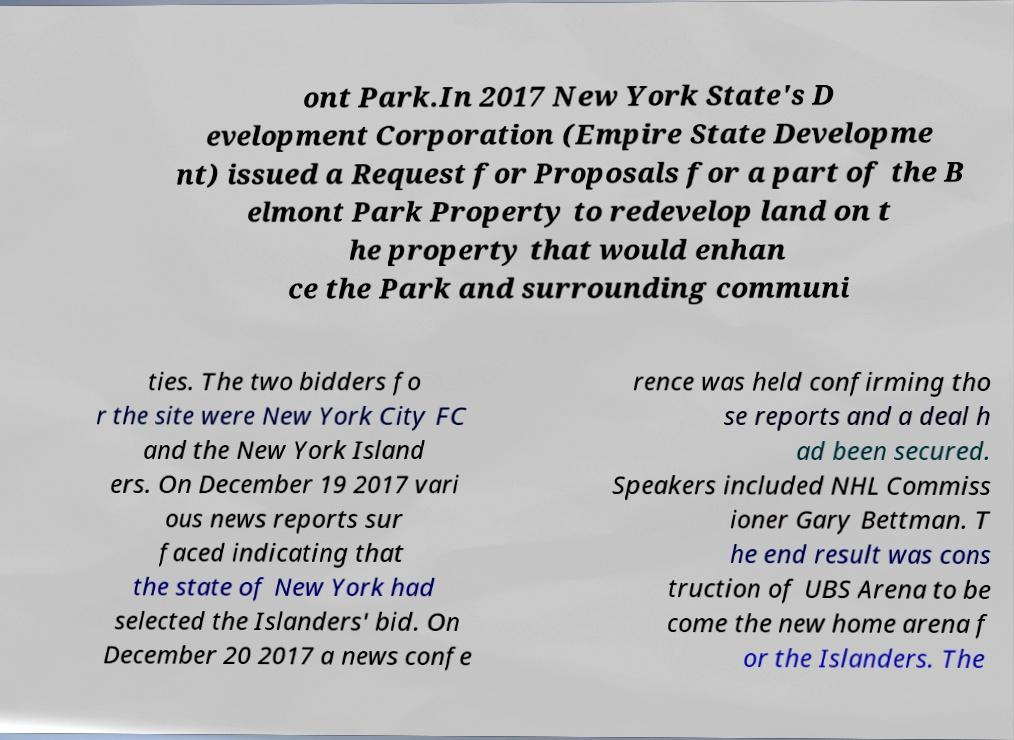For documentation purposes, I need the text within this image transcribed. Could you provide that? ont Park.In 2017 New York State's D evelopment Corporation (Empire State Developme nt) issued a Request for Proposals for a part of the B elmont Park Property to redevelop land on t he property that would enhan ce the Park and surrounding communi ties. The two bidders fo r the site were New York City FC and the New York Island ers. On December 19 2017 vari ous news reports sur faced indicating that the state of New York had selected the Islanders' bid. On December 20 2017 a news confe rence was held confirming tho se reports and a deal h ad been secured. Speakers included NHL Commiss ioner Gary Bettman. T he end result was cons truction of UBS Arena to be come the new home arena f or the Islanders. The 